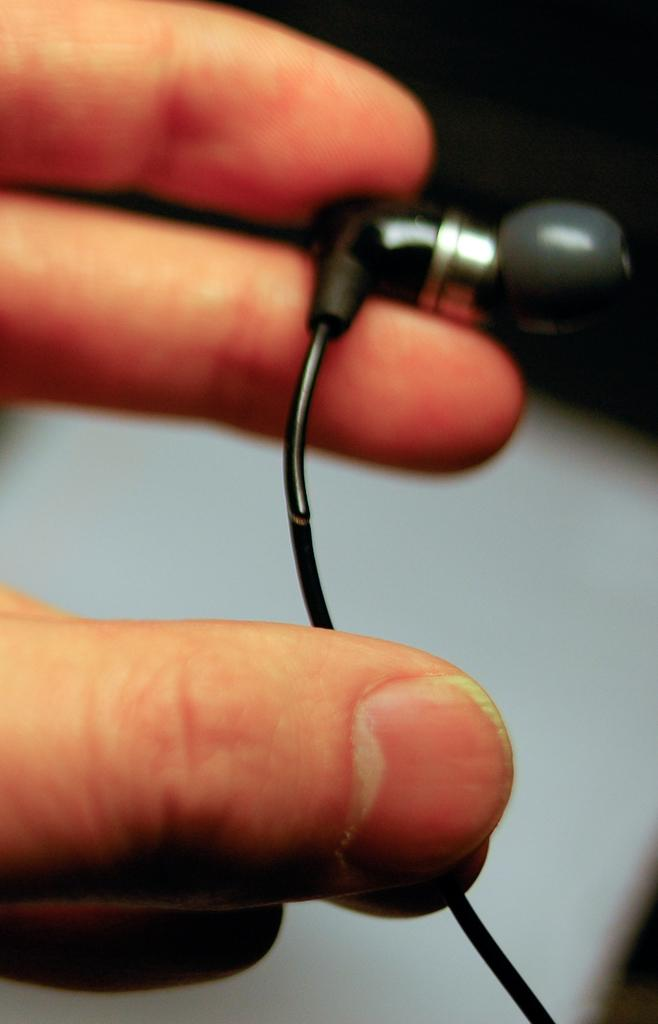What body parts are visible in the image? There are human hands in the image. What are the hands holding? The hands are holding earphones. What type of balloon is being used to sort the titles in the image? There is no balloon or sorting of titles present in the image; it only features human hands holding earphones. 